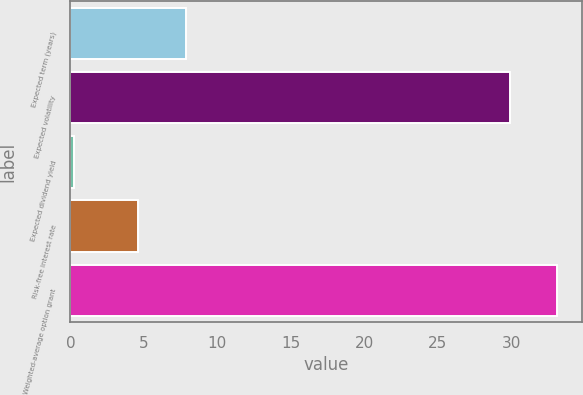Convert chart. <chart><loc_0><loc_0><loc_500><loc_500><bar_chart><fcel>Expected term (years)<fcel>Expected volatility<fcel>Expected dividend yield<fcel>Risk-free interest rate<fcel>Weighted-average option grant<nl><fcel>7.84<fcel>29.9<fcel>0.26<fcel>4.6<fcel>33.14<nl></chart> 